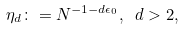Convert formula to latex. <formula><loc_0><loc_0><loc_500><loc_500>\eta _ { d } \colon = N ^ { - 1 - d \epsilon _ { 0 } } , \ d > 2 ,</formula> 